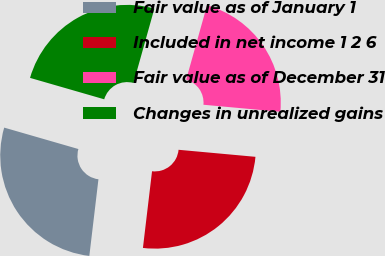<chart> <loc_0><loc_0><loc_500><loc_500><pie_chart><fcel>Fair value as of January 1<fcel>Included in net income 1 2 6<fcel>Fair value as of December 31<fcel>Changes in unrealized gains<nl><fcel>27.59%<fcel>25.43%<fcel>22.1%<fcel>24.88%<nl></chart> 